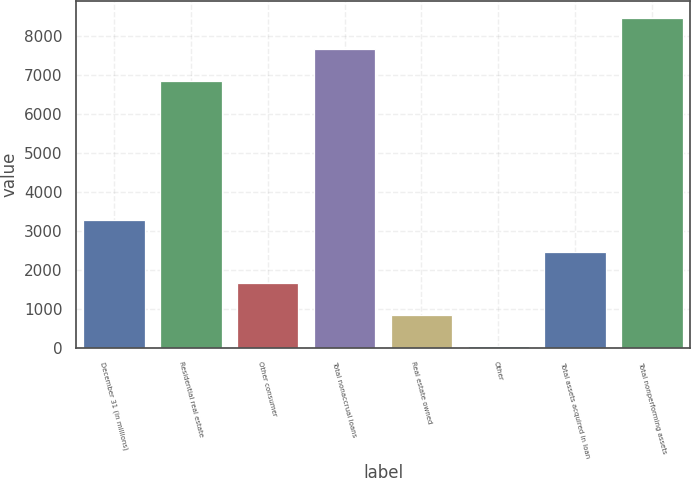Convert chart. <chart><loc_0><loc_0><loc_500><loc_500><bar_chart><fcel>December 31 (in millions)<fcel>Residential real estate<fcel>Other consumer<fcel>Total nonaccrual loans<fcel>Real estate owned<fcel>Other<fcel>Total assets acquired in loan<fcel>Total nonperforming assets<nl><fcel>3285<fcel>6864<fcel>1663<fcel>7675<fcel>852<fcel>41<fcel>2474<fcel>8486<nl></chart> 